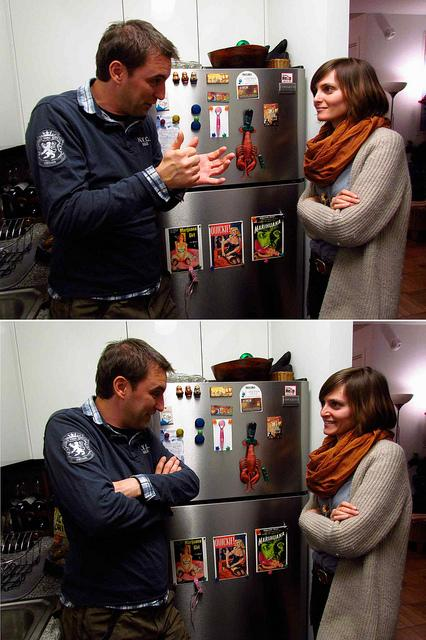How did the women feel about the man's remark? Please explain your reasoning. amused. The woman is laughing. 